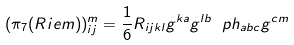Convert formula to latex. <formula><loc_0><loc_0><loc_500><loc_500>( \pi _ { 7 } ( R i e m ) ) ^ { m } _ { i j } = \frac { 1 } { 6 } R _ { i j k l } g ^ { k a } g ^ { l b } \ p h _ { a b c } g ^ { c m }</formula> 